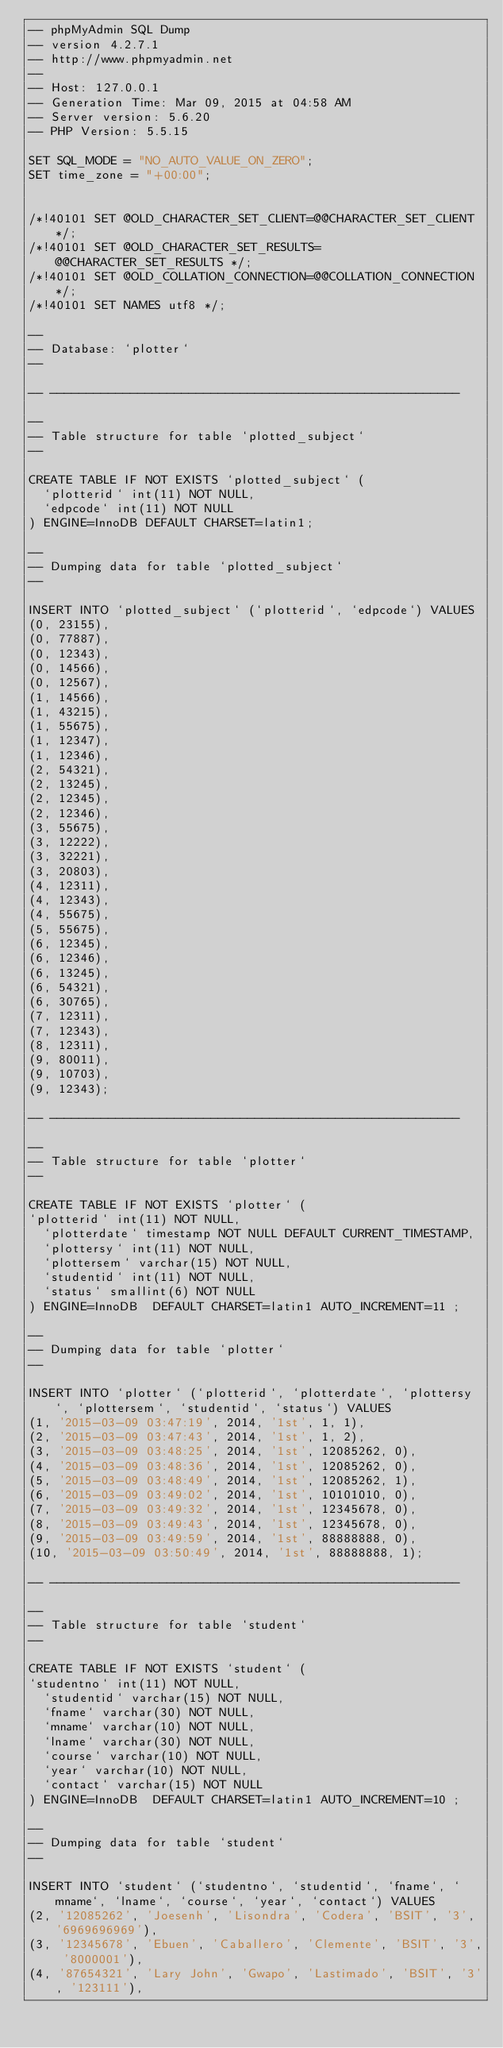<code> <loc_0><loc_0><loc_500><loc_500><_SQL_>-- phpMyAdmin SQL Dump
-- version 4.2.7.1
-- http://www.phpmyadmin.net
--
-- Host: 127.0.0.1
-- Generation Time: Mar 09, 2015 at 04:58 AM
-- Server version: 5.6.20
-- PHP Version: 5.5.15

SET SQL_MODE = "NO_AUTO_VALUE_ON_ZERO";
SET time_zone = "+00:00";


/*!40101 SET @OLD_CHARACTER_SET_CLIENT=@@CHARACTER_SET_CLIENT */;
/*!40101 SET @OLD_CHARACTER_SET_RESULTS=@@CHARACTER_SET_RESULTS */;
/*!40101 SET @OLD_COLLATION_CONNECTION=@@COLLATION_CONNECTION */;
/*!40101 SET NAMES utf8 */;

--
-- Database: `plotter`
--

-- --------------------------------------------------------

--
-- Table structure for table `plotted_subject`
--

CREATE TABLE IF NOT EXISTS `plotted_subject` (
  `plotterid` int(11) NOT NULL,
  `edpcode` int(11) NOT NULL
) ENGINE=InnoDB DEFAULT CHARSET=latin1;

--
-- Dumping data for table `plotted_subject`
--

INSERT INTO `plotted_subject` (`plotterid`, `edpcode`) VALUES
(0, 23155),
(0, 77887),
(0, 12343),
(0, 14566),
(0, 12567),
(1, 14566),
(1, 43215),
(1, 55675),
(1, 12347),
(1, 12346),
(2, 54321),
(2, 13245),
(2, 12345),
(2, 12346),
(3, 55675),
(3, 12222),
(3, 32221),
(3, 20803),
(4, 12311),
(4, 12343),
(4, 55675),
(5, 55675),
(6, 12345),
(6, 12346),
(6, 13245),
(6, 54321),
(6, 30765),
(7, 12311),
(7, 12343),
(8, 12311),
(9, 80011),
(9, 10703),
(9, 12343);

-- --------------------------------------------------------

--
-- Table structure for table `plotter`
--

CREATE TABLE IF NOT EXISTS `plotter` (
`plotterid` int(11) NOT NULL,
  `plotterdate` timestamp NOT NULL DEFAULT CURRENT_TIMESTAMP,
  `plottersy` int(11) NOT NULL,
  `plottersem` varchar(15) NOT NULL,
  `studentid` int(11) NOT NULL,
  `status` smallint(6) NOT NULL
) ENGINE=InnoDB  DEFAULT CHARSET=latin1 AUTO_INCREMENT=11 ;

--
-- Dumping data for table `plotter`
--

INSERT INTO `plotter` (`plotterid`, `plotterdate`, `plottersy`, `plottersem`, `studentid`, `status`) VALUES
(1, '2015-03-09 03:47:19', 2014, '1st', 1, 1),
(2, '2015-03-09 03:47:43', 2014, '1st', 1, 2),
(3, '2015-03-09 03:48:25', 2014, '1st', 12085262, 0),
(4, '2015-03-09 03:48:36', 2014, '1st', 12085262, 0),
(5, '2015-03-09 03:48:49', 2014, '1st', 12085262, 1),
(6, '2015-03-09 03:49:02', 2014, '1st', 10101010, 0),
(7, '2015-03-09 03:49:32', 2014, '1st', 12345678, 0),
(8, '2015-03-09 03:49:43', 2014, '1st', 12345678, 0),
(9, '2015-03-09 03:49:59', 2014, '1st', 88888888, 0),
(10, '2015-03-09 03:50:49', 2014, '1st', 88888888, 1);

-- --------------------------------------------------------

--
-- Table structure for table `student`
--

CREATE TABLE IF NOT EXISTS `student` (
`studentno` int(11) NOT NULL,
  `studentid` varchar(15) NOT NULL,
  `fname` varchar(30) NOT NULL,
  `mname` varchar(10) NOT NULL,
  `lname` varchar(30) NOT NULL,
  `course` varchar(10) NOT NULL,
  `year` varchar(10) NOT NULL,
  `contact` varchar(15) NOT NULL
) ENGINE=InnoDB  DEFAULT CHARSET=latin1 AUTO_INCREMENT=10 ;

--
-- Dumping data for table `student`
--

INSERT INTO `student` (`studentno`, `studentid`, `fname`, `mname`, `lname`, `course`, `year`, `contact`) VALUES
(2, '12085262', 'Joesenh', 'Lisondra', 'Codera', 'BSIT', '3', '6969696969'),
(3, '12345678', 'Ebuen', 'Caballero', 'Clemente', 'BSIT', '3', '8000001'),
(4, '87654321', 'Lary John', 'Gwapo', 'Lastimado', 'BSIT', '3', '123111'),</code> 